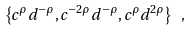Convert formula to latex. <formula><loc_0><loc_0><loc_500><loc_500>\left \{ c ^ { \rho } d ^ { - \rho } , c ^ { - 2 \rho } d ^ { - \rho } , c ^ { \rho } d ^ { 2 \rho } \right \} \ ,</formula> 